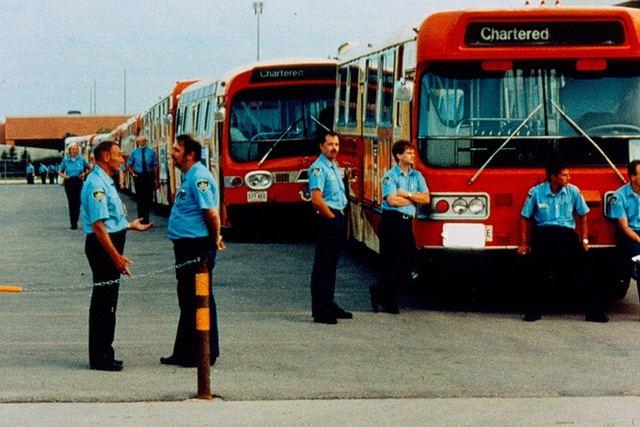Describe the objects in this image and their specific colors. I can see bus in lightblue, black, brown, teal, and maroon tones, bus in lightblue, black, maroon, and teal tones, people in lightblue, black, gray, teal, and maroon tones, people in lightblue, black, teal, and maroon tones, and people in lightblue, black, teal, and maroon tones in this image. 